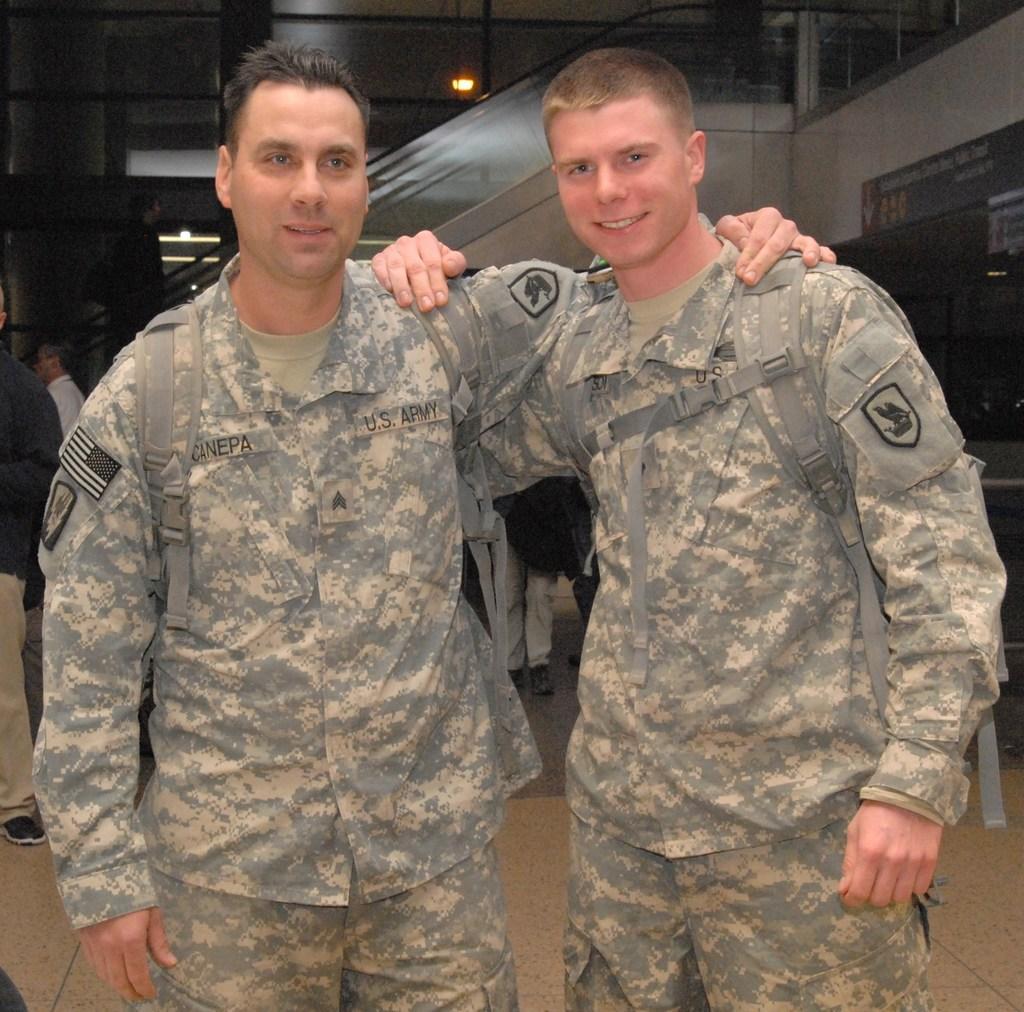In one or two sentences, can you explain what this image depicts? In the foreground of this image, there are two men standing having hands on their shoulder. In the background, there are few persons, wall, light, glass railing on the top and few objects on the right. 